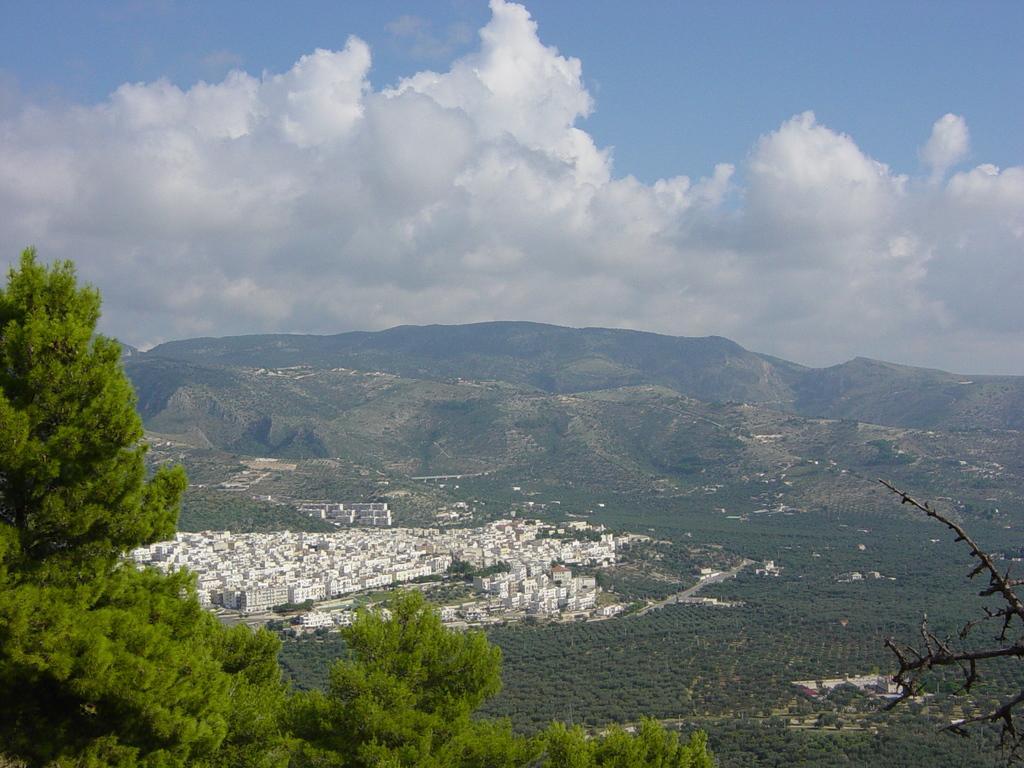Could you give a brief overview of what you see in this image? In this image in the foreground there are trees, and in the background there are mountains, buildings, trees and at the top there is sky. 